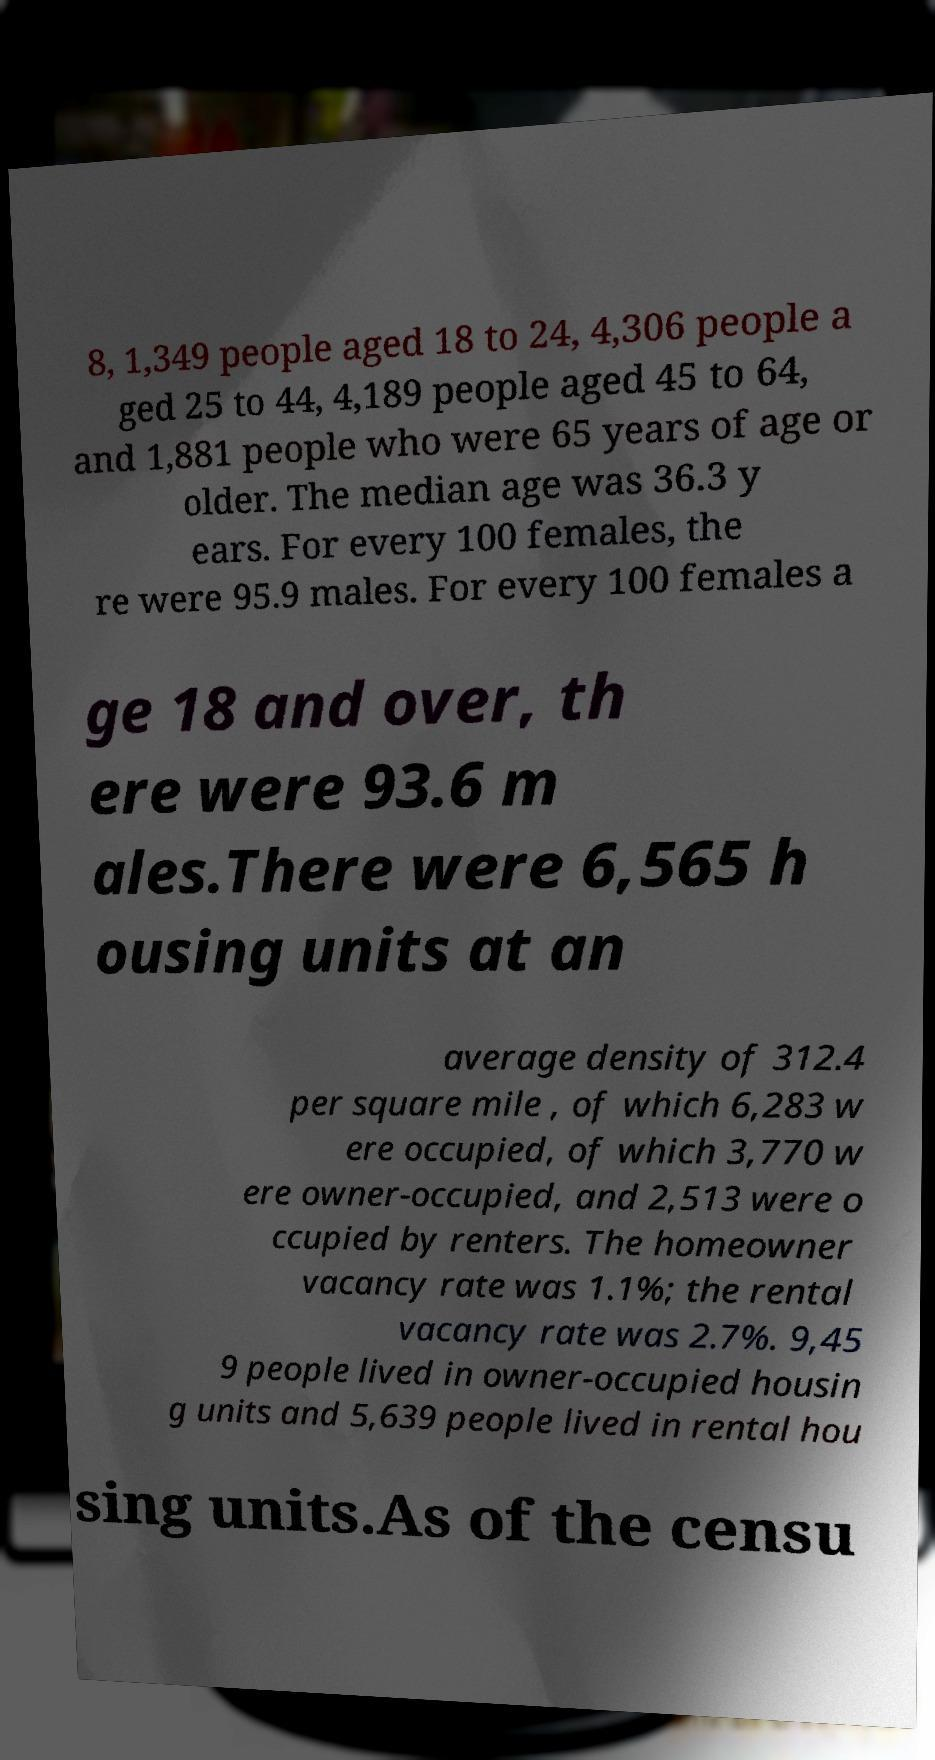Please identify and transcribe the text found in this image. 8, 1,349 people aged 18 to 24, 4,306 people a ged 25 to 44, 4,189 people aged 45 to 64, and 1,881 people who were 65 years of age or older. The median age was 36.3 y ears. For every 100 females, the re were 95.9 males. For every 100 females a ge 18 and over, th ere were 93.6 m ales.There were 6,565 h ousing units at an average density of 312.4 per square mile , of which 6,283 w ere occupied, of which 3,770 w ere owner-occupied, and 2,513 were o ccupied by renters. The homeowner vacancy rate was 1.1%; the rental vacancy rate was 2.7%. 9,45 9 people lived in owner-occupied housin g units and 5,639 people lived in rental hou sing units.As of the censu 